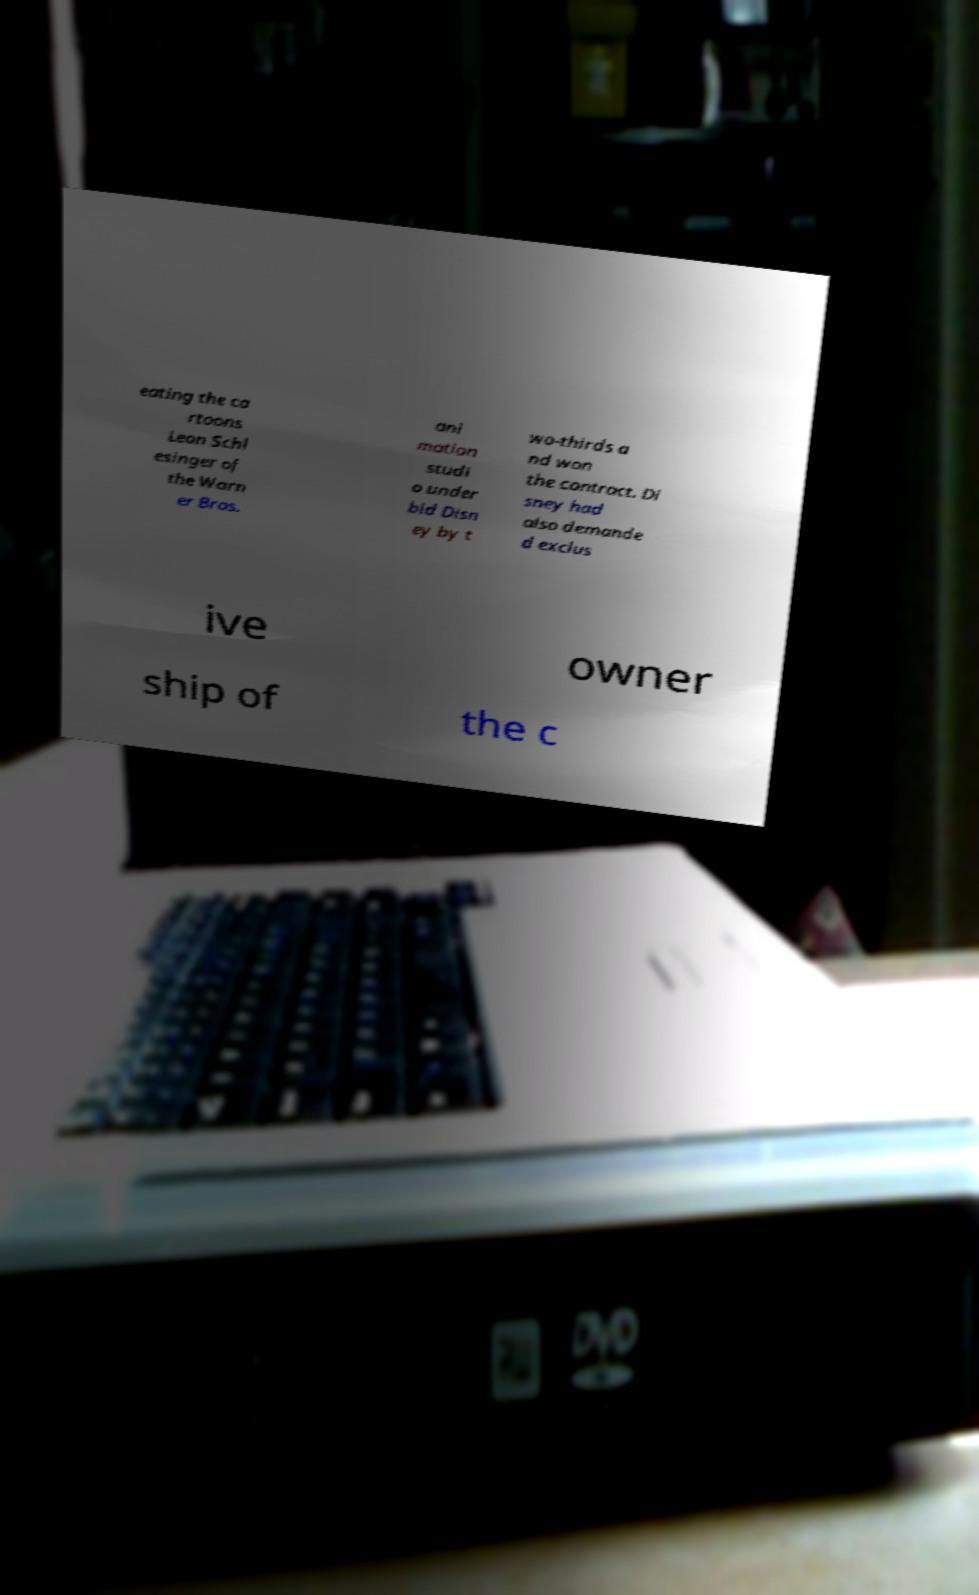Can you accurately transcribe the text from the provided image for me? eating the ca rtoons Leon Schl esinger of the Warn er Bros. ani mation studi o under bid Disn ey by t wo-thirds a nd won the contract. Di sney had also demande d exclus ive owner ship of the c 